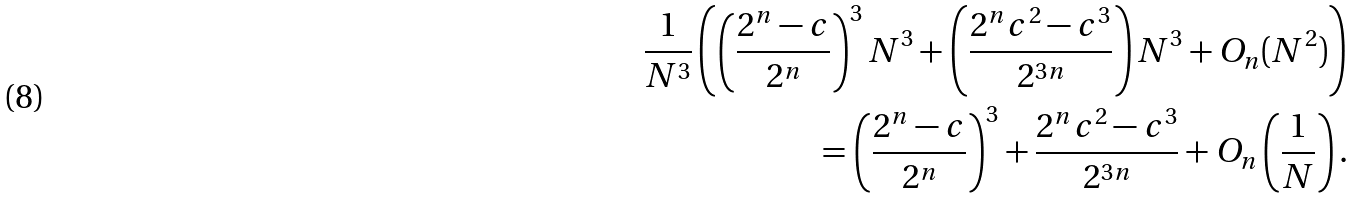Convert formula to latex. <formula><loc_0><loc_0><loc_500><loc_500>\frac { 1 } { N ^ { 3 } } \left ( \left ( \frac { 2 ^ { n } - c } { 2 ^ { n } } \right ) ^ { 3 } N ^ { 3 } + \left ( \frac { 2 ^ { n } c ^ { 2 } - c ^ { 3 } } { 2 ^ { 3 n } } \right ) N ^ { 3 } + O _ { n } ( N ^ { 2 } ) \right ) \\ \quad = \left ( \frac { 2 ^ { n } - c } { 2 ^ { n } } \right ) ^ { 3 } + \frac { 2 ^ { n } c ^ { 2 } - c ^ { 3 } } { 2 ^ { 3 n } } + O _ { n } \left ( \frac { 1 } { N } \right ) .</formula> 